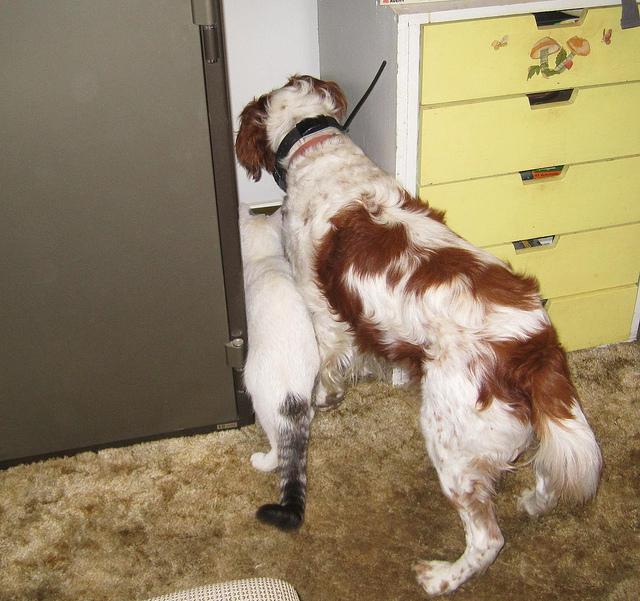What is on the dog's neck?
Quick response, please. Collar. Are these wild animals?
Quick response, please. No. What are they doing?
Answer briefly. Looking. 